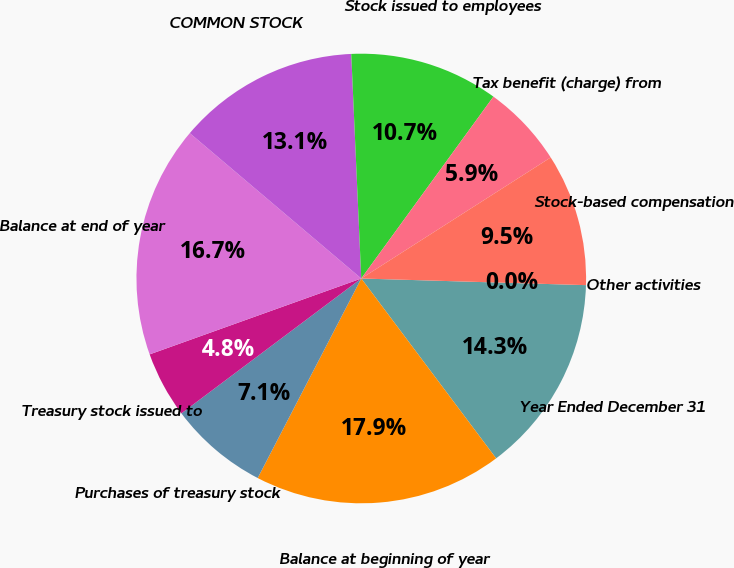Convert chart to OTSL. <chart><loc_0><loc_0><loc_500><loc_500><pie_chart><fcel>Year Ended December 31<fcel>Balance at beginning of year<fcel>Purchases of treasury stock<fcel>Treasury stock issued to<fcel>Balance at end of year<fcel>COMMON STOCK<fcel>Stock issued to employees<fcel>Tax benefit (charge) from<fcel>Stock-based compensation<fcel>Other activities<nl><fcel>14.29%<fcel>17.86%<fcel>7.14%<fcel>4.76%<fcel>16.67%<fcel>13.1%<fcel>10.71%<fcel>5.95%<fcel>9.52%<fcel>0.0%<nl></chart> 